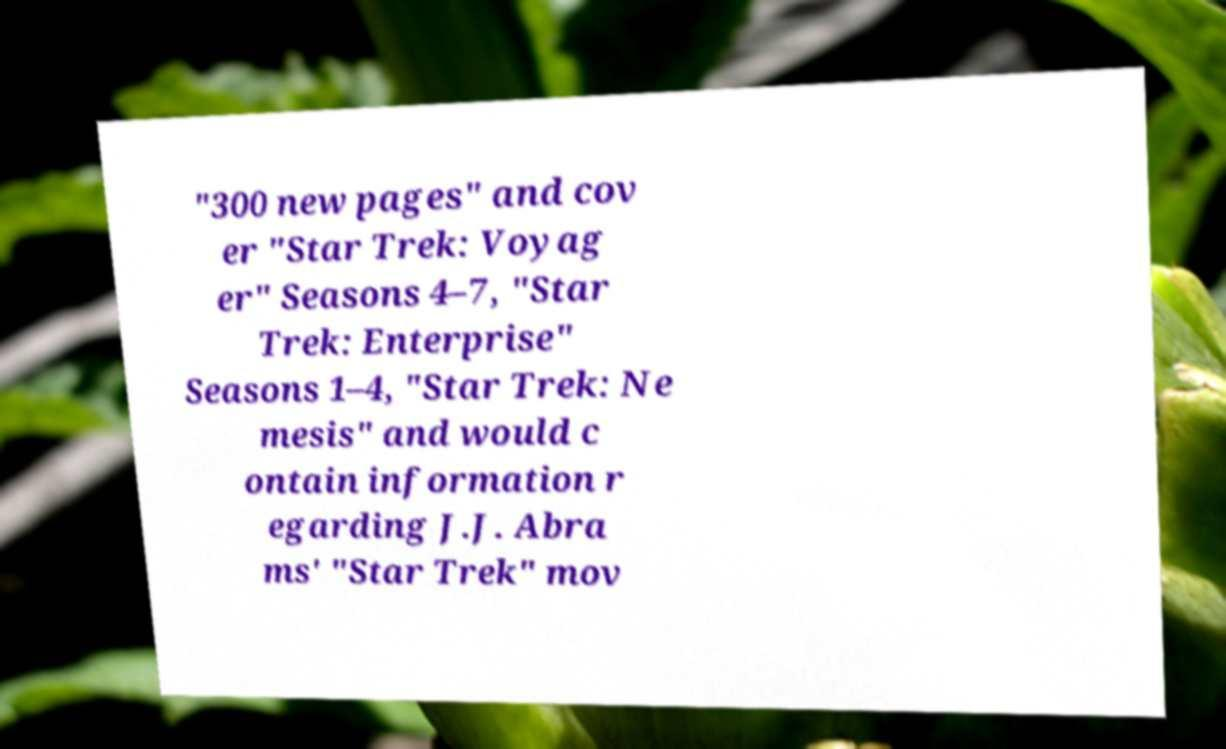Could you extract and type out the text from this image? "300 new pages" and cov er "Star Trek: Voyag er" Seasons 4–7, "Star Trek: Enterprise" Seasons 1–4, "Star Trek: Ne mesis" and would c ontain information r egarding J.J. Abra ms' "Star Trek" mov 